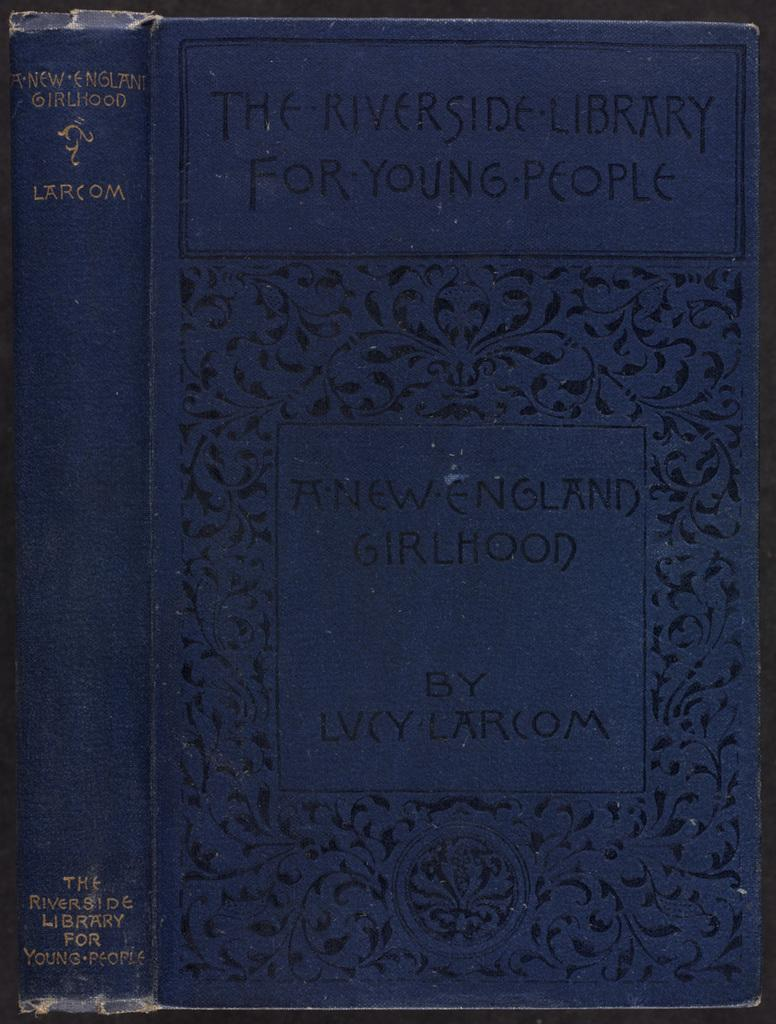<image>
Give a short and clear explanation of the subsequent image. An old copy of a book from The Riverside Library for Young People. 